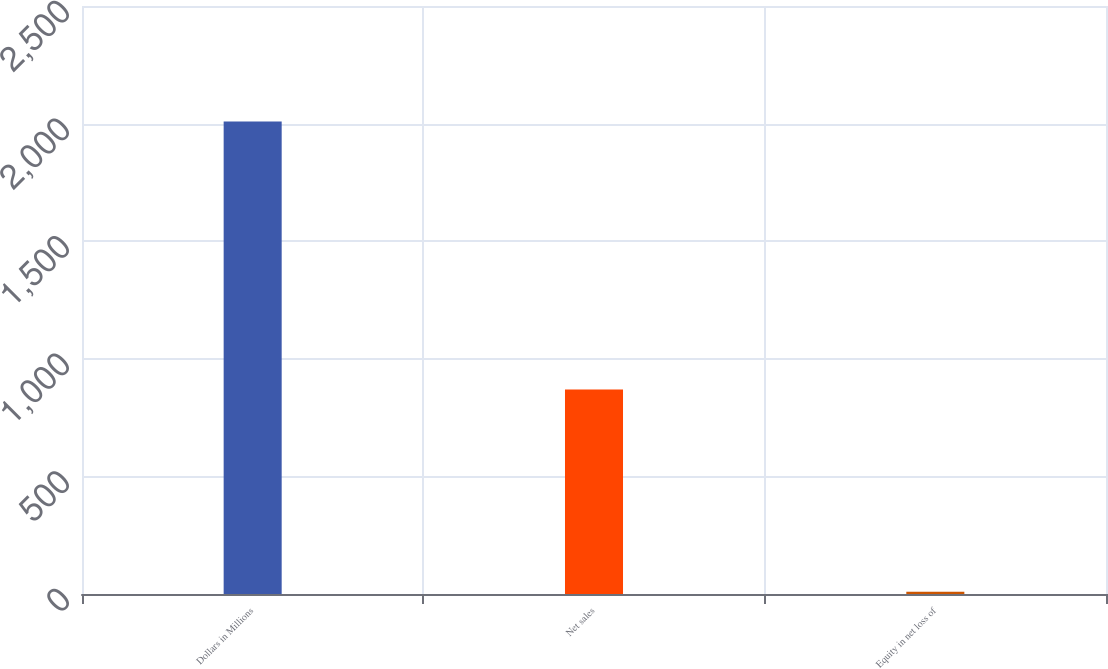<chart> <loc_0><loc_0><loc_500><loc_500><bar_chart><fcel>Dollars in Millions<fcel>Net sales<fcel>Equity in net loss of<nl><fcel>2009<fcel>869<fcel>10<nl></chart> 